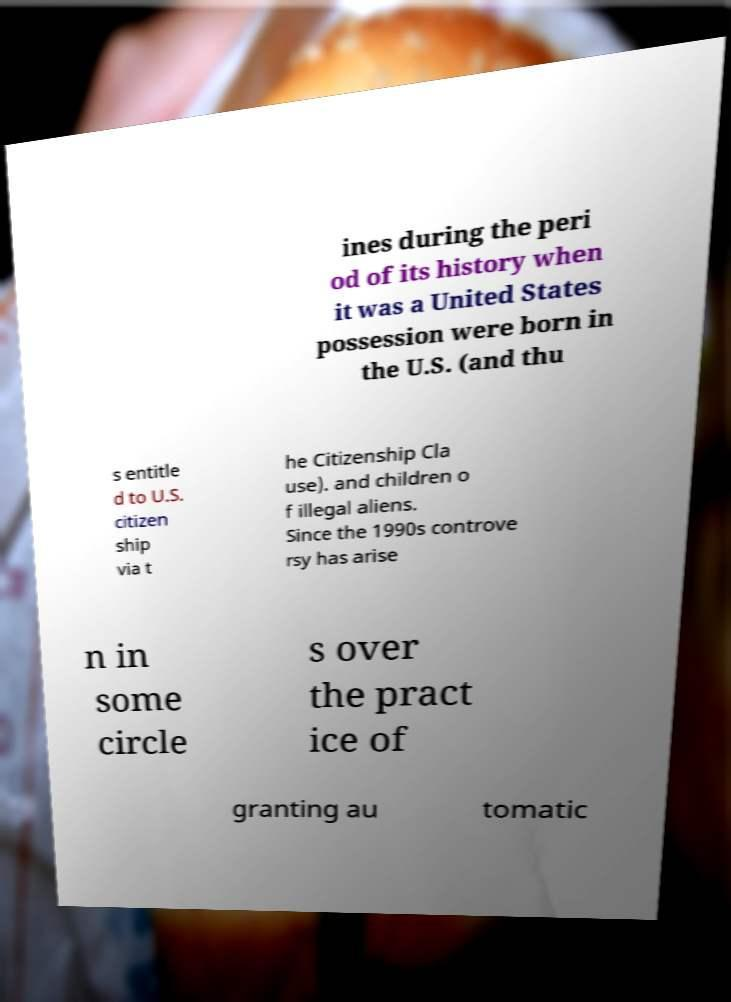What messages or text are displayed in this image? I need them in a readable, typed format. ines during the peri od of its history when it was a United States possession were born in the U.S. (and thu s entitle d to U.S. citizen ship via t he Citizenship Cla use). and children o f illegal aliens. Since the 1990s controve rsy has arise n in some circle s over the pract ice of granting au tomatic 